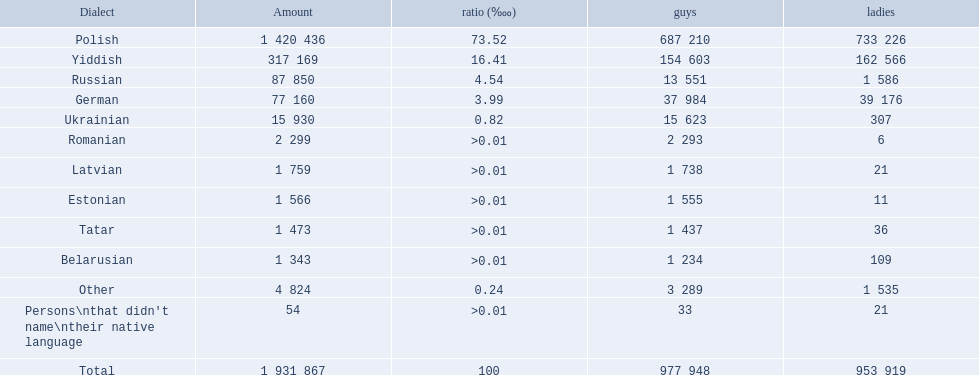What are all the languages? Polish, Yiddish, Russian, German, Ukrainian, Romanian, Latvian, Estonian, Tatar, Belarusian, Other, Persons\nthat didn't name\ntheir native language. Of those languages, which five had fewer than 50 females speaking it? 6, 21, 11, 36, 21. Of those five languages, which is the lowest? Romanian. 